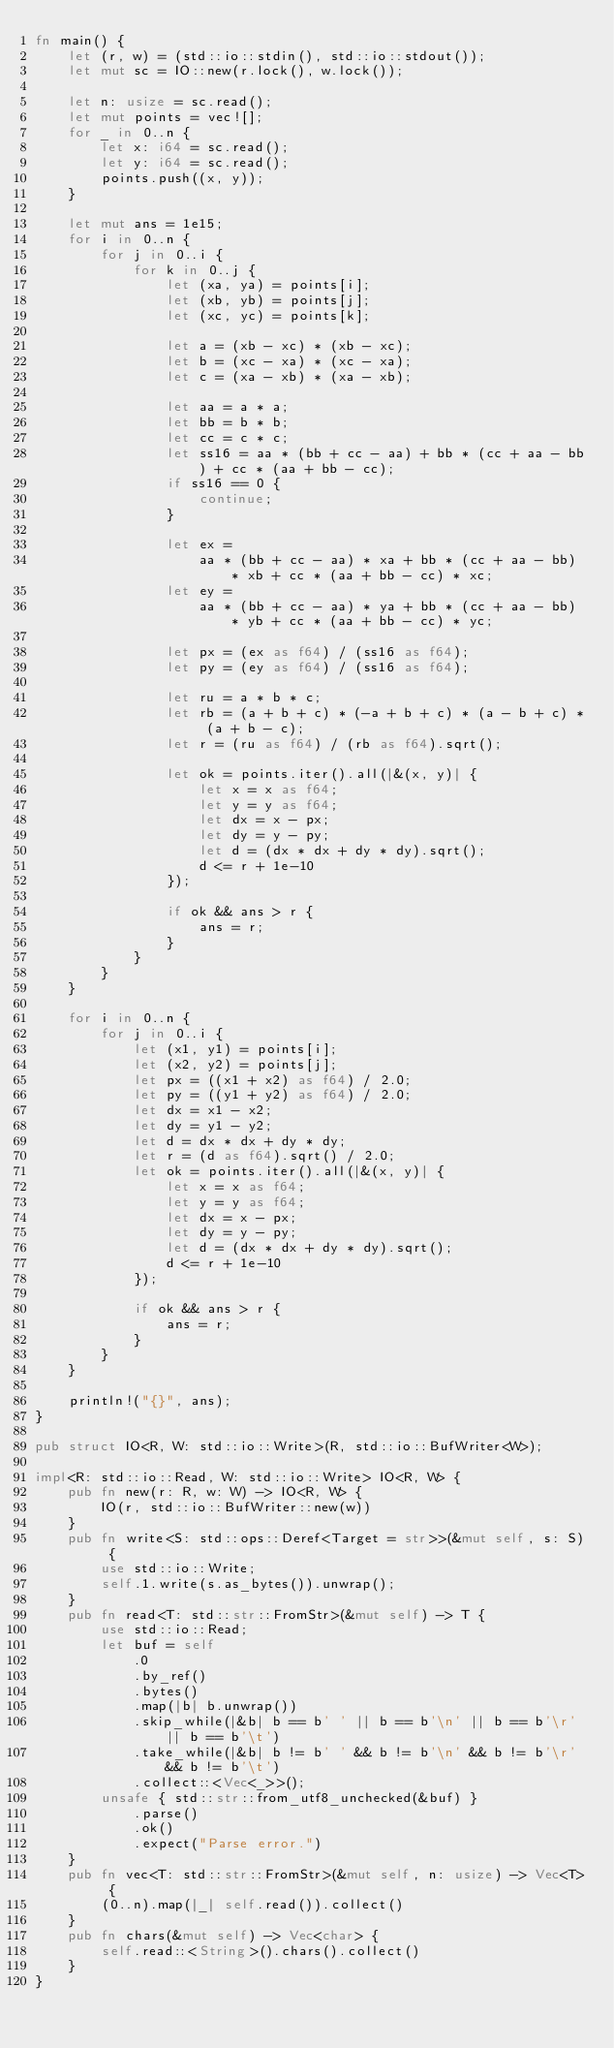<code> <loc_0><loc_0><loc_500><loc_500><_Rust_>fn main() {
    let (r, w) = (std::io::stdin(), std::io::stdout());
    let mut sc = IO::new(r.lock(), w.lock());

    let n: usize = sc.read();
    let mut points = vec![];
    for _ in 0..n {
        let x: i64 = sc.read();
        let y: i64 = sc.read();
        points.push((x, y));
    }

    let mut ans = 1e15;
    for i in 0..n {
        for j in 0..i {
            for k in 0..j {
                let (xa, ya) = points[i];
                let (xb, yb) = points[j];
                let (xc, yc) = points[k];

                let a = (xb - xc) * (xb - xc);
                let b = (xc - xa) * (xc - xa);
                let c = (xa - xb) * (xa - xb);

                let aa = a * a;
                let bb = b * b;
                let cc = c * c;
                let ss16 = aa * (bb + cc - aa) + bb * (cc + aa - bb) + cc * (aa + bb - cc);
                if ss16 == 0 {
                    continue;
                }

                let ex =
                    aa * (bb + cc - aa) * xa + bb * (cc + aa - bb) * xb + cc * (aa + bb - cc) * xc;
                let ey =
                    aa * (bb + cc - aa) * ya + bb * (cc + aa - bb) * yb + cc * (aa + bb - cc) * yc;

                let px = (ex as f64) / (ss16 as f64);
                let py = (ey as f64) / (ss16 as f64);

                let ru = a * b * c;
                let rb = (a + b + c) * (-a + b + c) * (a - b + c) * (a + b - c);
                let r = (ru as f64) / (rb as f64).sqrt();

                let ok = points.iter().all(|&(x, y)| {
                    let x = x as f64;
                    let y = y as f64;
                    let dx = x - px;
                    let dy = y - py;
                    let d = (dx * dx + dy * dy).sqrt();
                    d <= r + 1e-10
                });

                if ok && ans > r {
                    ans = r;
                }
            }
        }
    }

    for i in 0..n {
        for j in 0..i {
            let (x1, y1) = points[i];
            let (x2, y2) = points[j];
            let px = ((x1 + x2) as f64) / 2.0;
            let py = ((y1 + y2) as f64) / 2.0;
            let dx = x1 - x2;
            let dy = y1 - y2;
            let d = dx * dx + dy * dy;
            let r = (d as f64).sqrt() / 2.0;
            let ok = points.iter().all(|&(x, y)| {
                let x = x as f64;
                let y = y as f64;
                let dx = x - px;
                let dy = y - py;
                let d = (dx * dx + dy * dy).sqrt();
                d <= r + 1e-10
            });

            if ok && ans > r {
                ans = r;
            }
        }
    }

    println!("{}", ans);
}

pub struct IO<R, W: std::io::Write>(R, std::io::BufWriter<W>);

impl<R: std::io::Read, W: std::io::Write> IO<R, W> {
    pub fn new(r: R, w: W) -> IO<R, W> {
        IO(r, std::io::BufWriter::new(w))
    }
    pub fn write<S: std::ops::Deref<Target = str>>(&mut self, s: S) {
        use std::io::Write;
        self.1.write(s.as_bytes()).unwrap();
    }
    pub fn read<T: std::str::FromStr>(&mut self) -> T {
        use std::io::Read;
        let buf = self
            .0
            .by_ref()
            .bytes()
            .map(|b| b.unwrap())
            .skip_while(|&b| b == b' ' || b == b'\n' || b == b'\r' || b == b'\t')
            .take_while(|&b| b != b' ' && b != b'\n' && b != b'\r' && b != b'\t')
            .collect::<Vec<_>>();
        unsafe { std::str::from_utf8_unchecked(&buf) }
            .parse()
            .ok()
            .expect("Parse error.")
    }
    pub fn vec<T: std::str::FromStr>(&mut self, n: usize) -> Vec<T> {
        (0..n).map(|_| self.read()).collect()
    }
    pub fn chars(&mut self) -> Vec<char> {
        self.read::<String>().chars().collect()
    }
}
</code> 